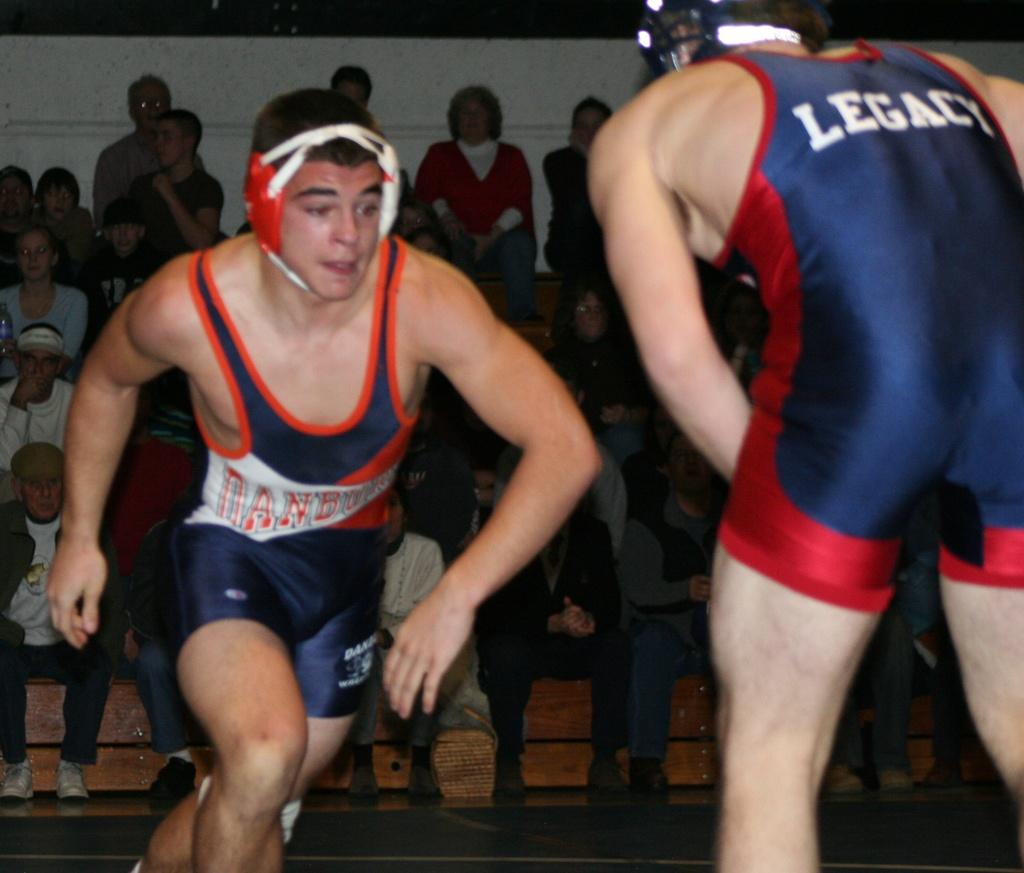<image>
Provide a brief description of the given image. Blue suit with Legacy wrote on the back. 